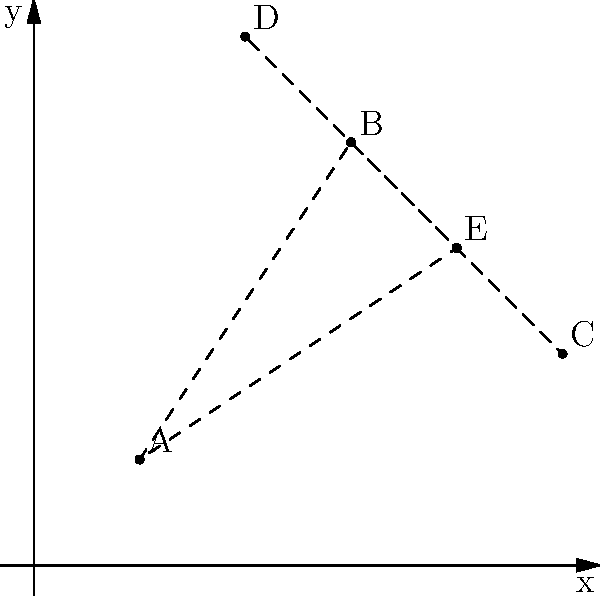As a tour guide in Arizona, you're planning a route to showcase unique shopping destinations. Five popular spots are marked on a coordinate plane: A(1,1), B(3,4), C(5,2), D(2,5), and E(4,3). What is the shortest possible route that visits all these locations exactly once and returns to the starting point? Give your answer as the total distance traveled, rounded to two decimal places. To find the shortest route, we need to calculate the distances between all pairs of points and then determine the shortest path that visits all points once and returns to the start. This is known as the Traveling Salesman Problem.

Step 1: Calculate distances between all pairs of points using the distance formula:
$d = \sqrt{(x_2-x_1)^2 + (y_2-y_1)^2}$

AB = $\sqrt{(3-1)^2 + (4-1)^2} = \sqrt{13}$
AC = $\sqrt{(5-1)^2 + (2-1)^2} = \sqrt{17}$
AD = $\sqrt{(2-1)^2 + (5-1)^2} = \sqrt{17}$
AE = $\sqrt{(4-1)^2 + (3-1)^2} = \sqrt{13}$
BC = $\sqrt{(5-3)^2 + (2-4)^2} = \sqrt{8}$
BD = $\sqrt{(2-3)^2 + (5-4)^2} = \sqrt{2}$
BE = $\sqrt{(4-3)^2 + (3-4)^2} = \sqrt{2}$
CD = $\sqrt{(2-5)^2 + (5-2)^2} = \sqrt{18}$
CE = $\sqrt{(4-5)^2 + (3-2)^2} = \sqrt{2}$
DE = $\sqrt{(4-2)^2 + (3-5)^2} = \sqrt{8}$

Step 2: Find the shortest path. In this case, the optimal route is A-B-D-E-C-A.

Step 3: Calculate the total distance:
Total distance = AB + BD + DE + EC + CA
               = $\sqrt{13} + \sqrt{2} + \sqrt{8} + \sqrt{2} + \sqrt{17}$
               ≈ 3.61 + 1.41 + 2.83 + 1.41 + 4.12
               ≈ 13.38

Step 4: Round to two decimal places: 13.38
Answer: 13.38 units 